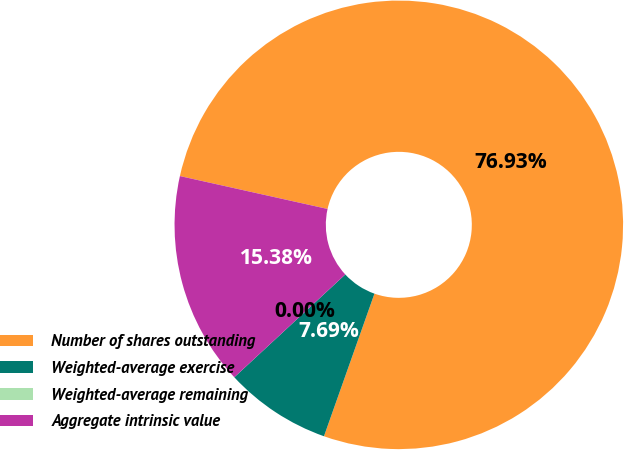Convert chart. <chart><loc_0><loc_0><loc_500><loc_500><pie_chart><fcel>Number of shares outstanding<fcel>Weighted-average exercise<fcel>Weighted-average remaining<fcel>Aggregate intrinsic value<nl><fcel>76.92%<fcel>7.69%<fcel>0.0%<fcel>15.38%<nl></chart> 